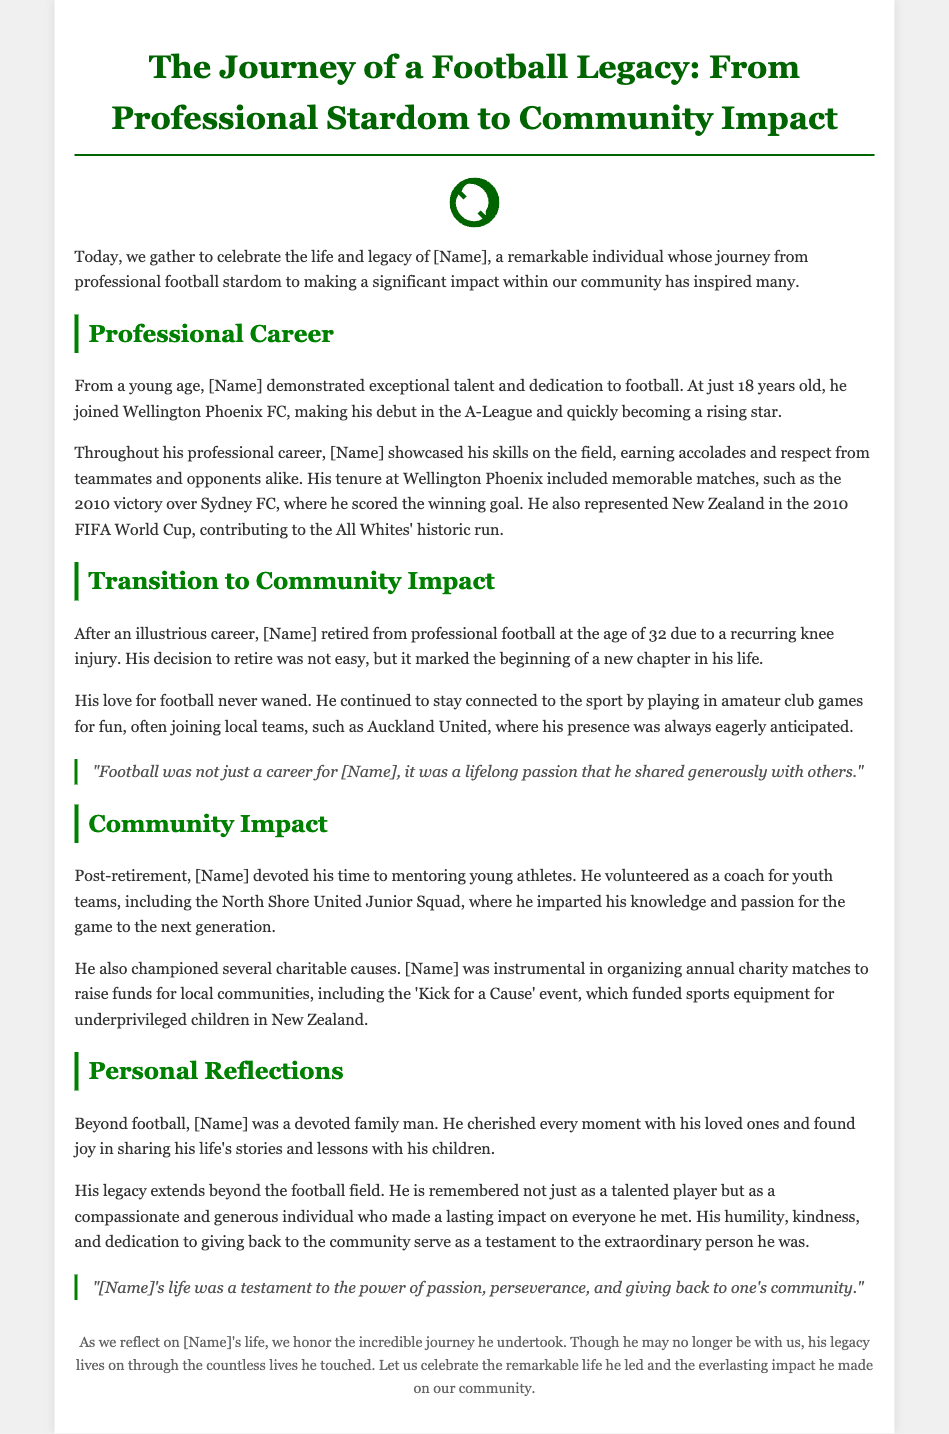What was the name of the individual being honored? The document celebrates the life and legacy of a remarkable individual, [Name], who is a football player.
Answer: [Name] Which club did [Name] join at the age of 18? [Name] demonstrated exceptional talent and joined Wellington Phoenix FC at just 18 years old.
Answer: Wellington Phoenix FC What significant event did [Name] participate in during 2010? [Name] represented New Zealand in the 2010 FIFA World Cup, contributing to the All Whites' historic run.
Answer: 2010 FIFA World Cup How old was [Name] when he retired from professional football? The document states that he retired from professional football at the age of 32.
Answer: 32 What charitable event did [Name] help organize? [Name] was instrumental in organizing annual charity matches, including the 'Kick for a Cause' event.
Answer: Kick for a Cause What role did [Name] take on after retirement? After retiring, [Name] devoted his time to mentoring young athletes and volunteered as a coach for youth teams.
Answer: Coach What is remembered as a key trait of [Name]? The document highlights [Name]'s humility, kindness, and dedication to giving back to the community.
Answer: Humility What did [Name] find joy in besides football? Beyond football, [Name] cherished every moment with his loved ones and shared his life's stories with his children.
Answer: Family What does the document emphasize about [Name]'s life besides his football career? It emphasizes that [Name]'s legacy extends beyond the football field as he made a lasting impact on everyone he met.
Answer: Lasting impact 